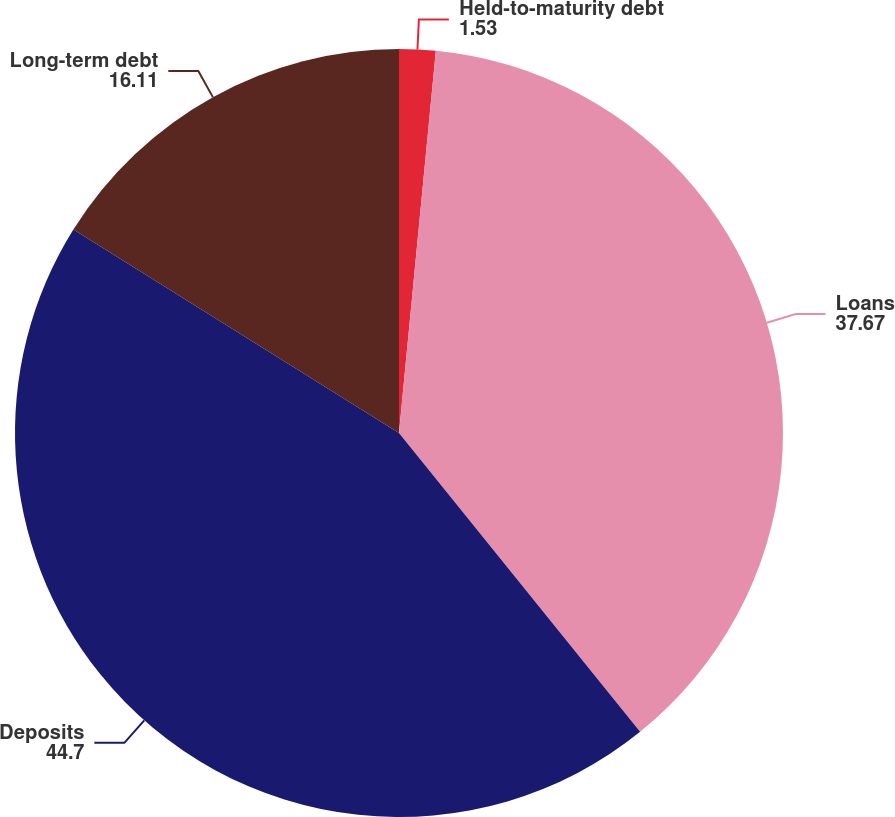<chart> <loc_0><loc_0><loc_500><loc_500><pie_chart><fcel>Held-to-maturity debt<fcel>Loans<fcel>Deposits<fcel>Long-term debt<nl><fcel>1.53%<fcel>37.67%<fcel>44.7%<fcel>16.11%<nl></chart> 